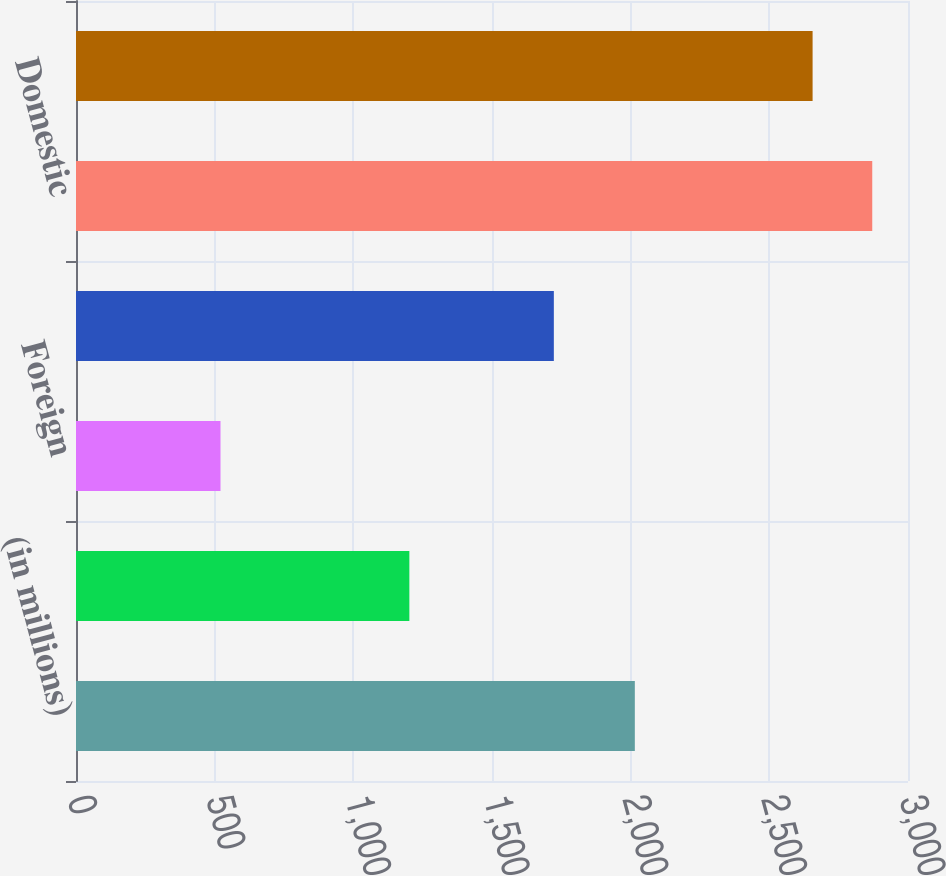<chart> <loc_0><loc_0><loc_500><loc_500><bar_chart><fcel>(in millions)<fcel>Domestic ^(d)(e)<fcel>Foreign<fcel>Total Non-Life Insurance<fcel>Domestic<fcel>Total Life Insurance Companies<nl><fcel>2015<fcel>1202<fcel>521<fcel>1723<fcel>2871.1<fcel>2656<nl></chart> 